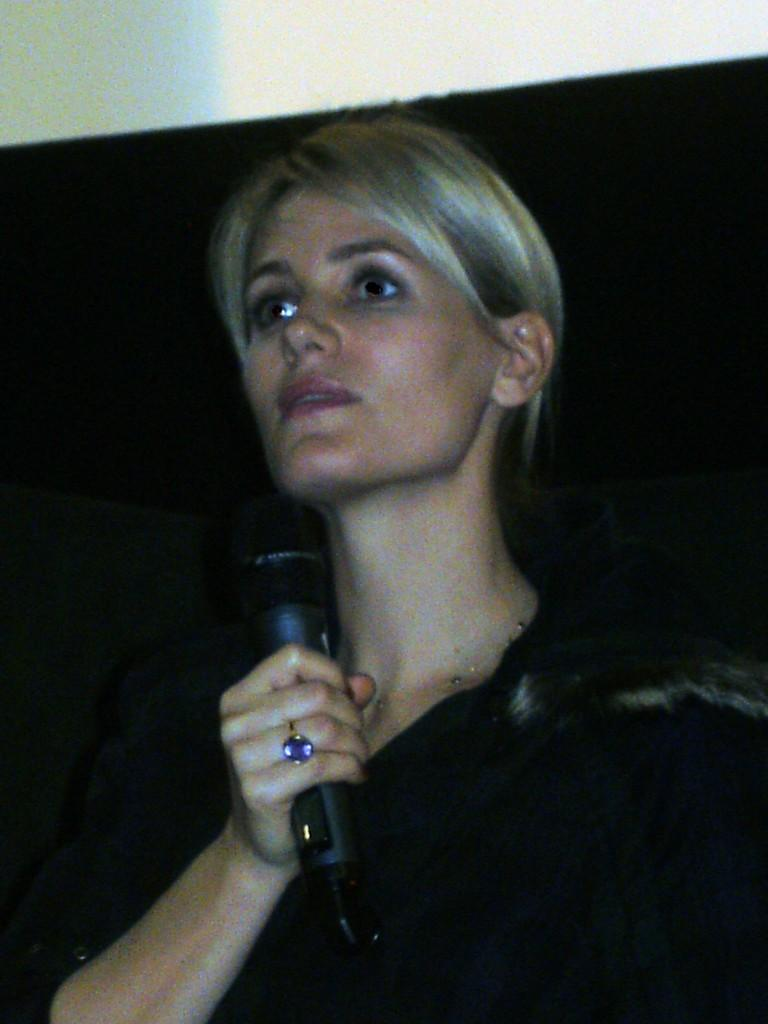Who is the main subject in the image? There is a woman in the image. What is the woman holding in the image? The woman is holding a mic. What color is the background of the image? The background of the image is black. Can you see a guitar being played by the woman in the image? There is no guitar present in the image, and the woman is not shown playing any instrument. 